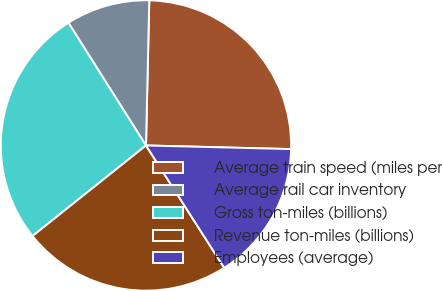Convert chart. <chart><loc_0><loc_0><loc_500><loc_500><pie_chart><fcel>Average train speed (miles per<fcel>Average rail car inventory<fcel>Gross ton-miles (billions)<fcel>Revenue ton-miles (billions)<fcel>Employees (average)<nl><fcel>25.04%<fcel>9.33%<fcel>26.75%<fcel>23.33%<fcel>15.55%<nl></chart> 